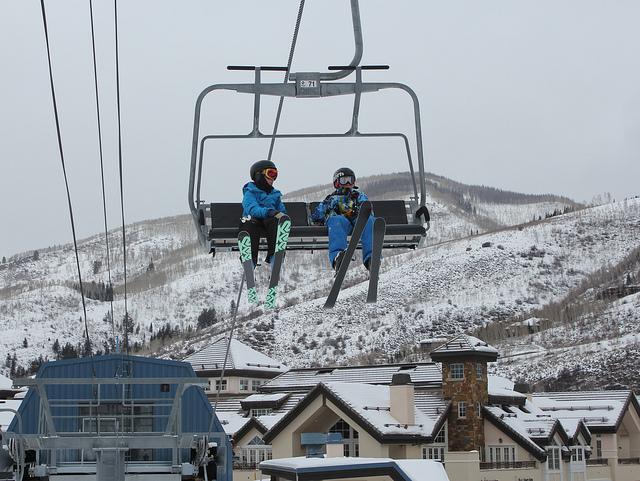How many people are wearing hats?
Give a very brief answer. 2. What is the kid doing?
Write a very short answer. Skiing. How many people are on the lift?
Give a very brief answer. 2. Are they going up or down the hill?
Be succinct. Up. What are the chains for?
Write a very short answer. Ski lift. Who is in the carrier?
Short answer required. Skiers. How many people are in the carrier?
Quick response, please. 2. Is it daytime?
Keep it brief. Yes. What is the man playing?
Keep it brief. Skiing. What color pants is the person wearing?
Quick response, please. Blue. 